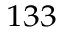<formula> <loc_0><loc_0><loc_500><loc_500>^ { 1 3 3 }</formula> 